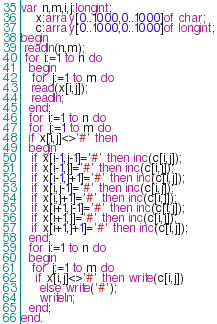<code> <loc_0><loc_0><loc_500><loc_500><_Pascal_>var n,m,i,j:longint;
    x:array[0..1000,0..1000]of char;
    c:array[0..1000,0..1000]of longint;
begin
 readln(n,m);
 for i:=1 to n do
  begin
   for j:=1 to m do
   read(x[i,j]);
   readln;
  end;
  for i:=1 to n do
  for j:=1 to m do
  if x[i,j]<>'#' then
  begin
   if x[i-1,j-1]='#' then inc(c[i,j]);
   if x[i-1,j]='#' then inc(c[i,j]);
   if x[i-1,j+1]='#' then inc(c[i,j]);
   if x[i,j-1]='#' then inc(c[i,j]);
   if x[i,j+1]='#' then inc(c[i,j]);
   if x[i+1,j-1]='#' then inc(c[i,j]);
   if x[i+1,j]='#' then inc(c[i,j]);
   if x[i+1,j+1]='#' then inc(c[i,j]);
  end;
  for i:=1 to n do
  begin
   for j:=1 to m do
    if x[i,j]<>'#' then write(c[i,j])
     else write('#');
     writeln;
  end;
end.
</code> 